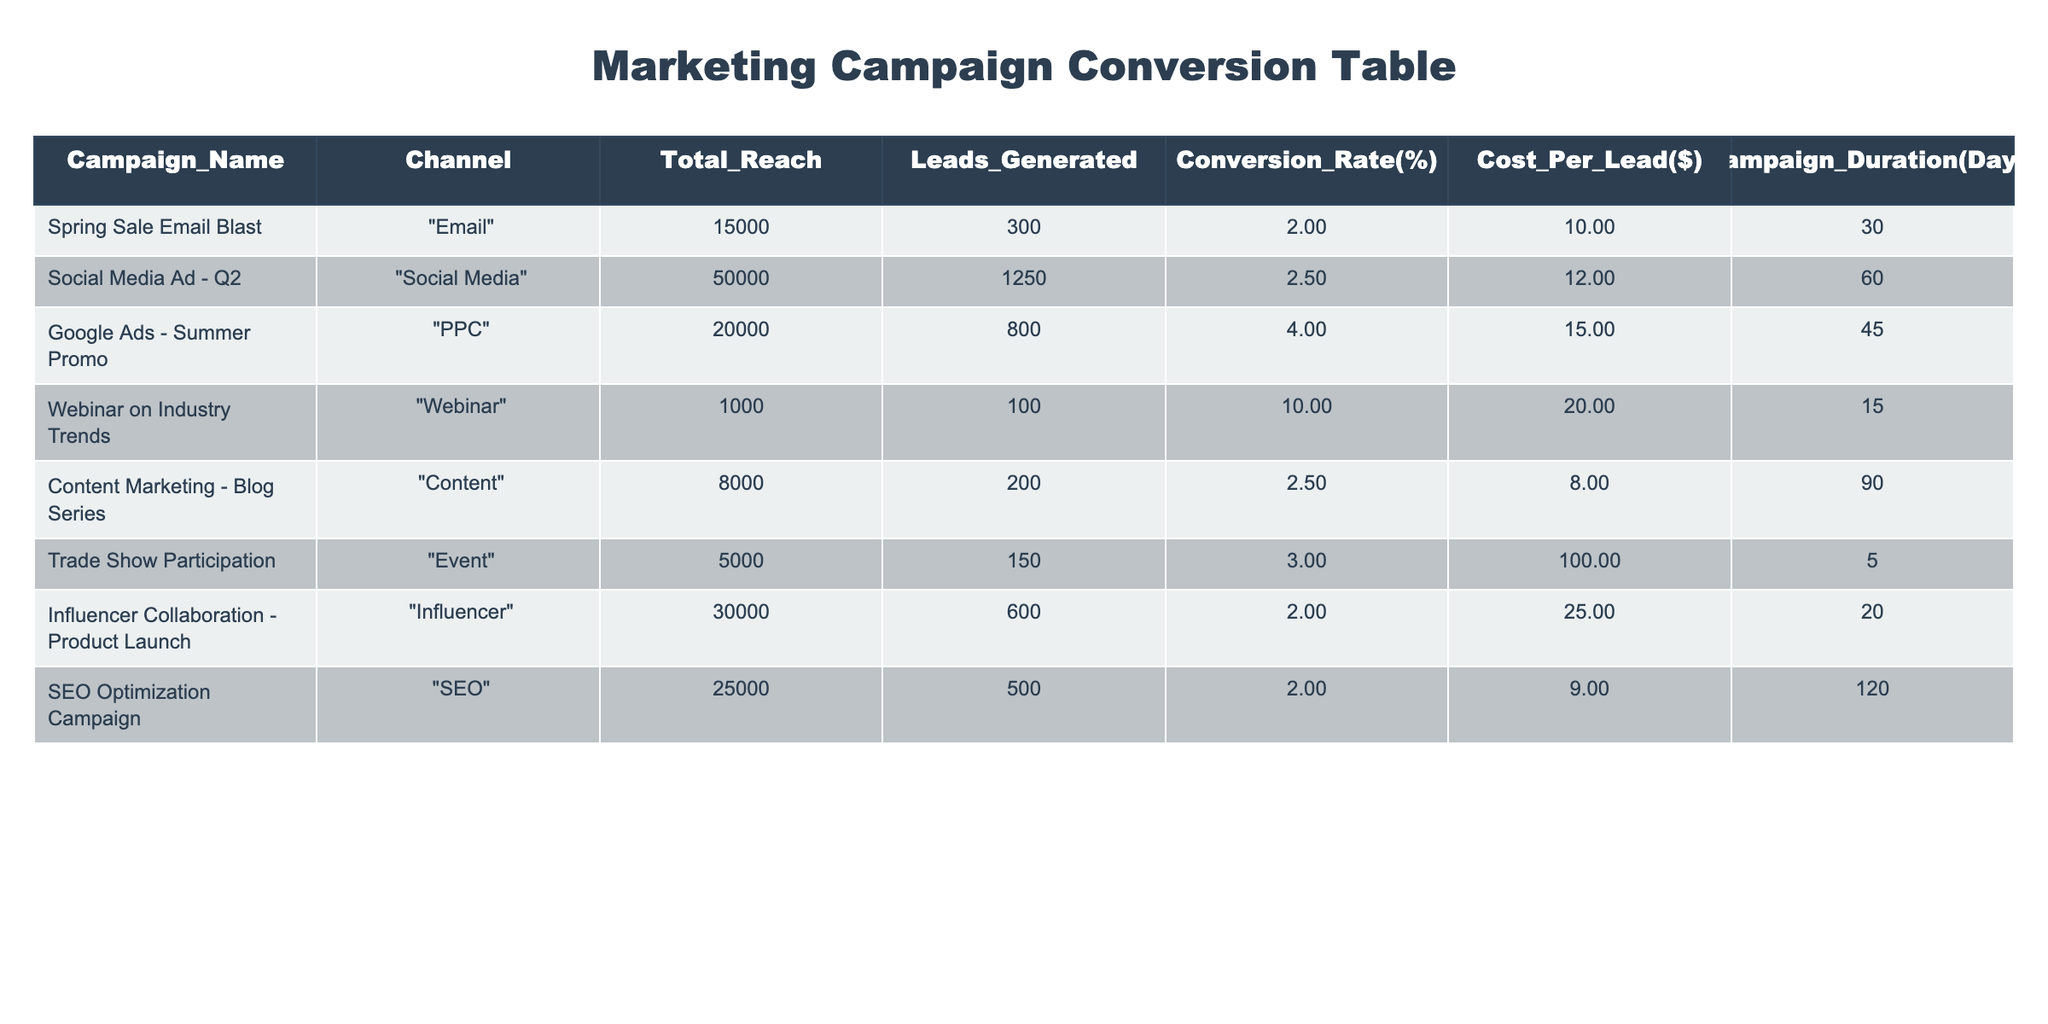What's the total reach of the "Google Ads - Summer Promo" campaign? The reach for the "Google Ads - Summer Promo" campaign is directly listed in the table under the "Total_Reach" column. It shows a value of 20000.
Answer: 20000 What is the conversion rate for the "Webinar on Industry Trends" campaign? The conversion rate for the "Webinar on Industry Trends" is found in the table under the "Conversion_Rate(%)" column, which indicates it at 10.00%.
Answer: 10.00% Which campaign had the highest cost per lead? The campaign with the highest cost per lead can be identified by comparing the "Cost_Per_Lead($)" values in the table. The "Trade Show Participation" campaign has a cost per lead of $100, which is the highest among all campaigns.
Answer: Trade Show Participation What is the average conversion rate across all campaigns? To calculate the average conversion rate, sum the conversion rates of all campaigns and divide by the total number of campaigns. The sum is (2.00 + 2.50 + 4.00 + 10.00 + 2.50 + 3.00 + 2.00 + 2.00) = 28.00, and there are 8 campaigns, so the average is 28.00 / 8 = 3.50.
Answer: 3.50 Is the "Influencer Collaboration - Product Launch" campaign more effective than the "Social Media Ad - Q2" campaign in generating leads based on conversion rate? The conversion rate for the "Influencer Collaboration - Product Launch" is 2.00%, while the "Social Media Ad - Q2" campaign has a conversion rate of 2.50%. Since 2.00% is less than 2.50%, the "Influencer Collaboration" campaign is less effective in this regard.
Answer: No Which campaign had the longest duration, and how many days did it last? The duration of each campaign is compared by examining the "Campaign_Duration(Days)" column. The "SEO Optimization Campaign" has the longest duration at 120 days.
Answer: SEO Optimization Campaign, 120 days How much total cost was incurred for the leads generated by the "Content Marketing - Blog Series" campaign? The total cost for a campaign can be calculated by multiplying the "Cost_Per_Lead($)" by the number of leads generated. For the "Content Marketing - Blog Series," it generated 200 leads at a cost of $8 per lead, resulting in a total cost of 200 * 8 = $1600.
Answer: $1600 What is the difference in leads generated between the "Social Media Ad - Q2" and the "Email" campaign? To find the difference in leads generated, subtract the number of leads generated by the "Spring Sale Email Blast" (300 leads) from that of the "Social Media Ad - Q2" (1250 leads), which results in 1250 - 300 = 950 leads.
Answer: 950 leads Which channel generated the least number of leads, and how many leads did it generate? A review of the "Leads_Generated" column indicates that the "Webinar on Industry Trends" campaign generated the least number of leads with a total of 100.
Answer: Webinar on Industry Trends, 100 leads 